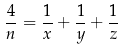Convert formula to latex. <formula><loc_0><loc_0><loc_500><loc_500>\frac { 4 } { n } = \frac { 1 } { x } + \frac { 1 } { y } + \frac { 1 } { z }</formula> 